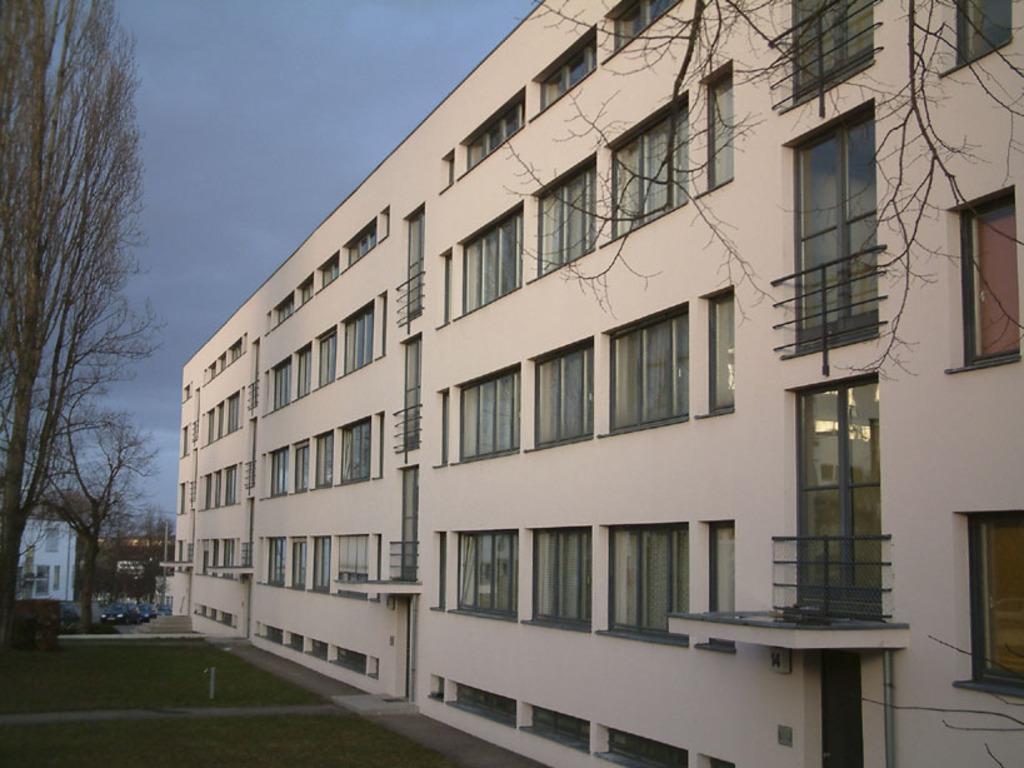Could you give a brief overview of what you see in this image? Here in this picture we can see a building present on the ground over there and we can see windows on the building over there and in the left side we can see trees present all over there and we can see a car present in the far and we can see clouds in the sky. 